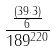Convert formula to latex. <formula><loc_0><loc_0><loc_500><loc_500>\frac { \frac { ( 3 9 \cdot 3 ) } { 6 } } { 1 8 9 ^ { 2 2 0 } }</formula> 